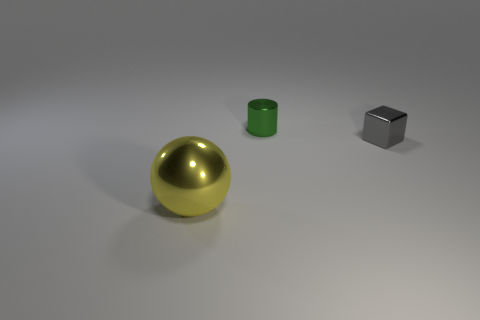Add 3 large yellow metallic objects. How many objects exist? 6 Add 1 cubes. How many cubes are left? 2 Add 2 green things. How many green things exist? 3 Subtract 0 yellow cylinders. How many objects are left? 3 Subtract all balls. How many objects are left? 2 Subtract all small cyan shiny blocks. Subtract all small gray blocks. How many objects are left? 2 